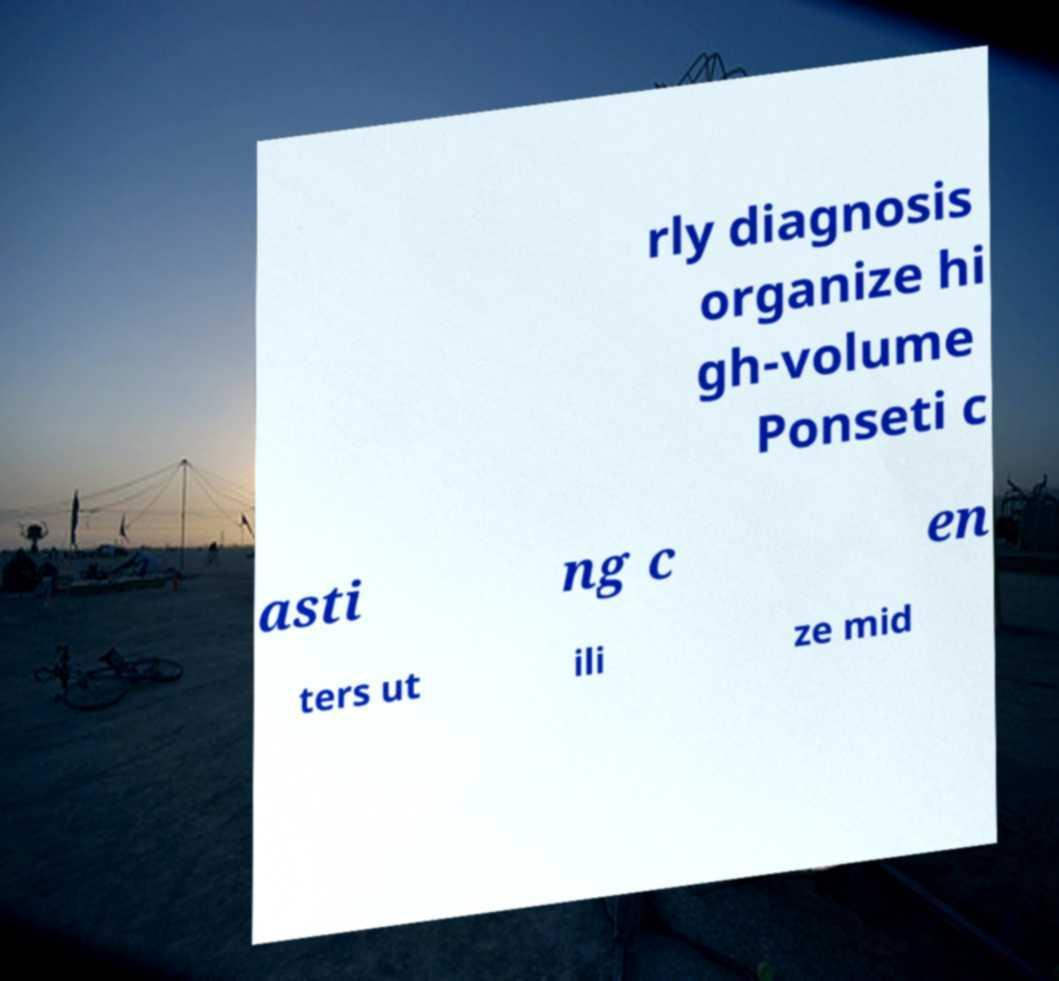I need the written content from this picture converted into text. Can you do that? rly diagnosis organize hi gh-volume Ponseti c asti ng c en ters ut ili ze mid 